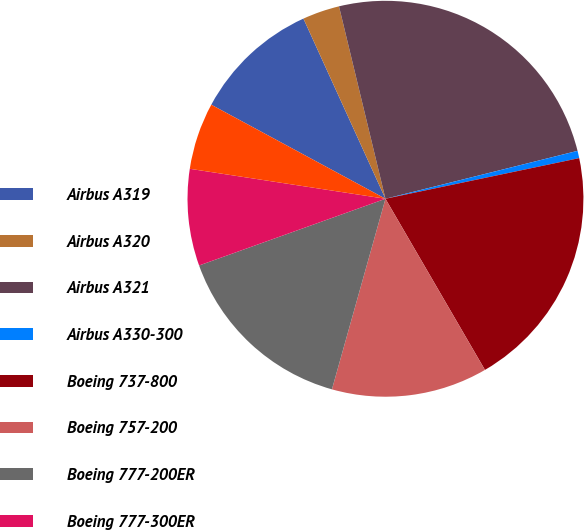Convert chart to OTSL. <chart><loc_0><loc_0><loc_500><loc_500><pie_chart><fcel>Airbus A319<fcel>Airbus A320<fcel>Airbus A321<fcel>Airbus A330-300<fcel>Boeing 737-800<fcel>Boeing 757-200<fcel>Boeing 777-200ER<fcel>Boeing 777-300ER<fcel>McDonnell Douglas MD-80<nl><fcel>10.32%<fcel>3.03%<fcel>24.88%<fcel>0.6%<fcel>19.91%<fcel>12.74%<fcel>15.17%<fcel>7.89%<fcel>5.46%<nl></chart> 